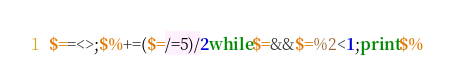Convert code to text. <code><loc_0><loc_0><loc_500><loc_500><_Perl_>$==<>;$%+=($=/=5)/2while$=&&$=%2<1;print$%</code> 